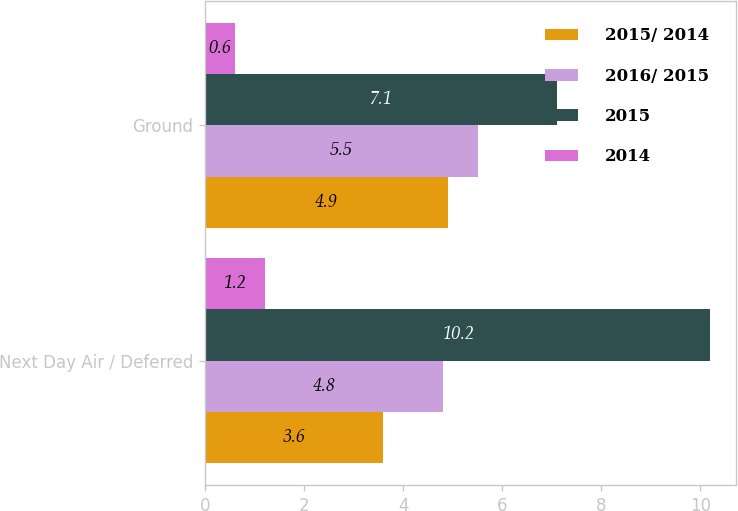Convert chart. <chart><loc_0><loc_0><loc_500><loc_500><stacked_bar_chart><ecel><fcel>Next Day Air / Deferred<fcel>Ground<nl><fcel>2015/ 2014<fcel>3.6<fcel>4.9<nl><fcel>2016/ 2015<fcel>4.8<fcel>5.5<nl><fcel>2015<fcel>10.2<fcel>7.1<nl><fcel>2014<fcel>1.2<fcel>0.6<nl></chart> 